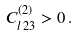<formula> <loc_0><loc_0><loc_500><loc_500>C ^ { ( 2 ) } _ { l \, 2 3 } > 0 \, .</formula> 